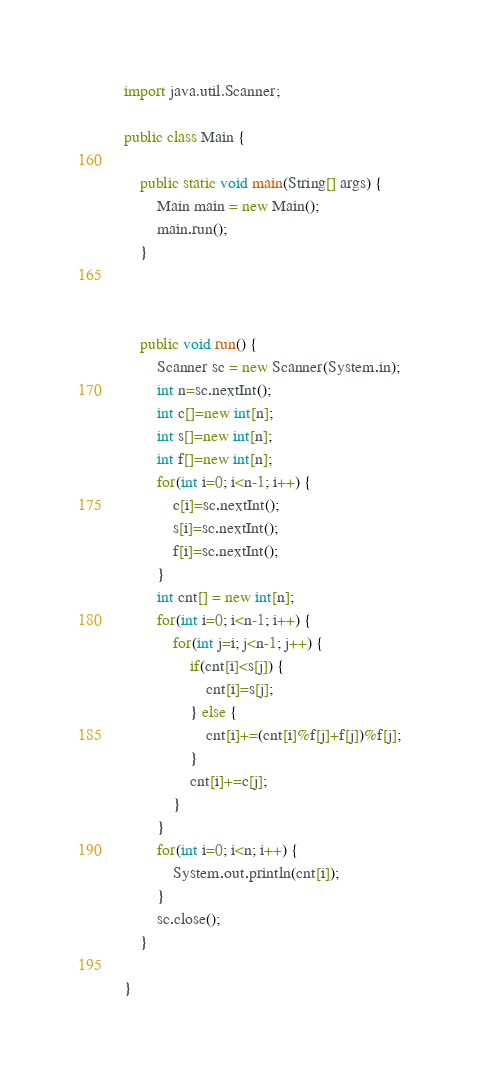<code> <loc_0><loc_0><loc_500><loc_500><_Java_>
import java.util.Scanner;

public class Main {

	public static void main(String[] args) {
		Main main = new Main();
		main.run();
	}



	public void run() {
		Scanner sc = new Scanner(System.in);
		int n=sc.nextInt();
		int c[]=new int[n];
		int s[]=new int[n];
		int f[]=new int[n];
		for(int i=0; i<n-1; i++) {
			c[i]=sc.nextInt();
			s[i]=sc.nextInt();
			f[i]=sc.nextInt();
		}
		int cnt[] = new int[n];
		for(int i=0; i<n-1; i++) {
			for(int j=i; j<n-1; j++) {
				if(cnt[i]<s[j]) {
					cnt[i]=s[j];
				} else {
					cnt[i]+=(cnt[i]%f[j]+f[j])%f[j];
				}
				cnt[i]+=c[j];
			}
		}
		for(int i=0; i<n; i++) {
			System.out.println(cnt[i]);
		}
		sc.close();
	}

}
</code> 